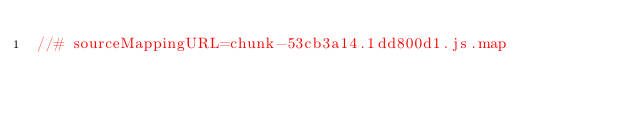<code> <loc_0><loc_0><loc_500><loc_500><_JavaScript_>//# sourceMappingURL=chunk-53cb3a14.1dd800d1.js.map</code> 